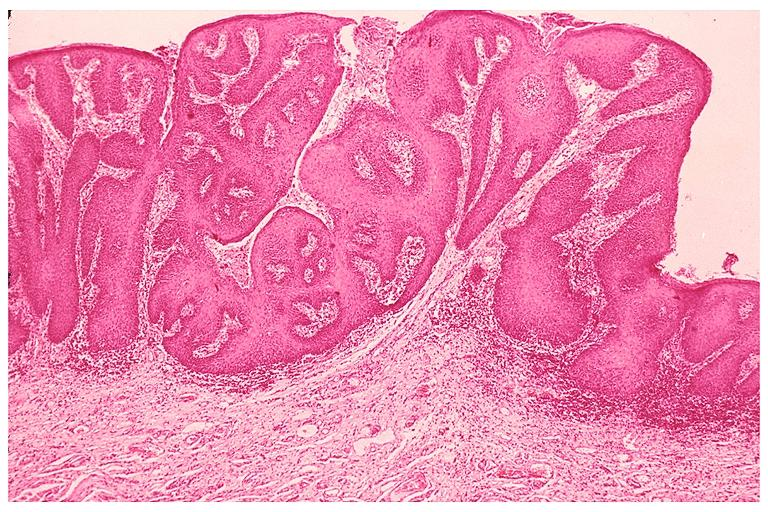does one show inflamatory papillary hyperplasia?
Answer the question using a single word or phrase. No 